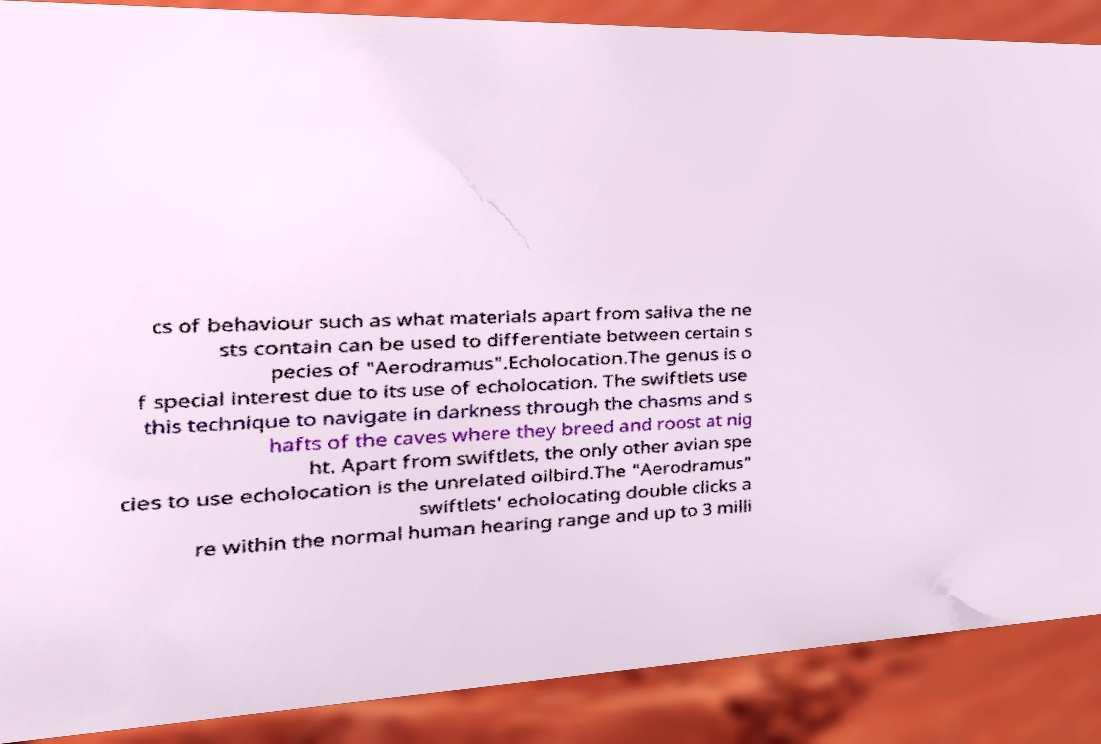Can you accurately transcribe the text from the provided image for me? cs of behaviour such as what materials apart from saliva the ne sts contain can be used to differentiate between certain s pecies of "Aerodramus".Echolocation.The genus is o f special interest due to its use of echolocation. The swiftlets use this technique to navigate in darkness through the chasms and s hafts of the caves where they breed and roost at nig ht. Apart from swiftlets, the only other avian spe cies to use echolocation is the unrelated oilbird.The "Aerodramus" swiftlets' echolocating double clicks a re within the normal human hearing range and up to 3 milli 